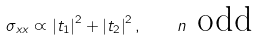Convert formula to latex. <formula><loc_0><loc_0><loc_500><loc_500>\sigma _ { x x } \varpropto \left | t _ { 1 } \right | ^ { 2 } + \left | t _ { 2 } \right | ^ { 2 } , \quad n \text { odd}</formula> 